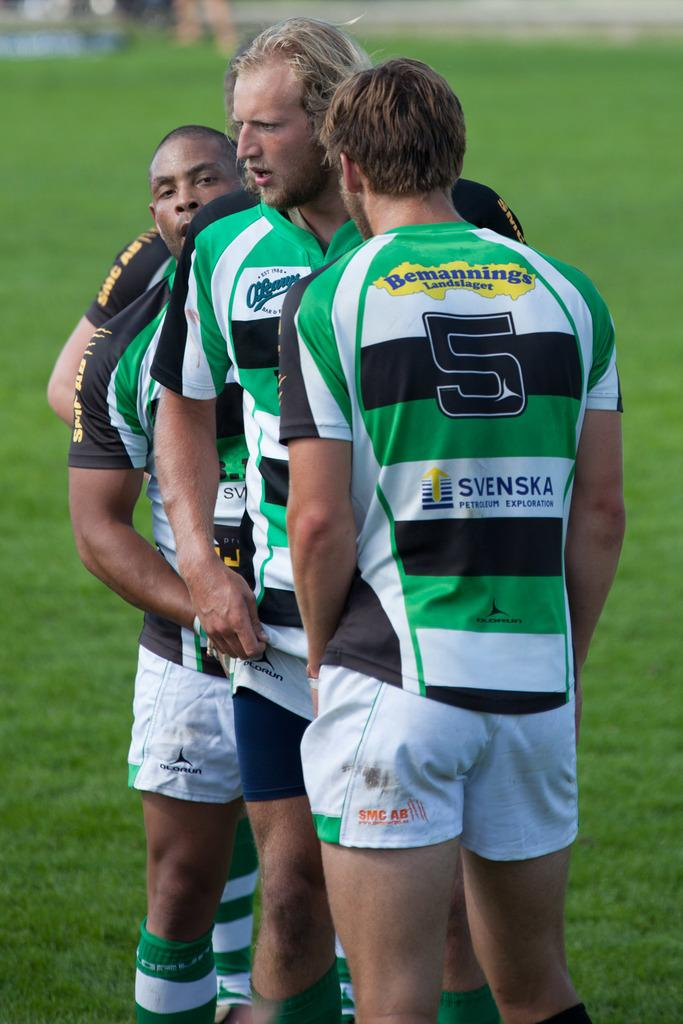<image>
Write a terse but informative summary of the picture. Player number 5 stands in a row with some of his teammates. 